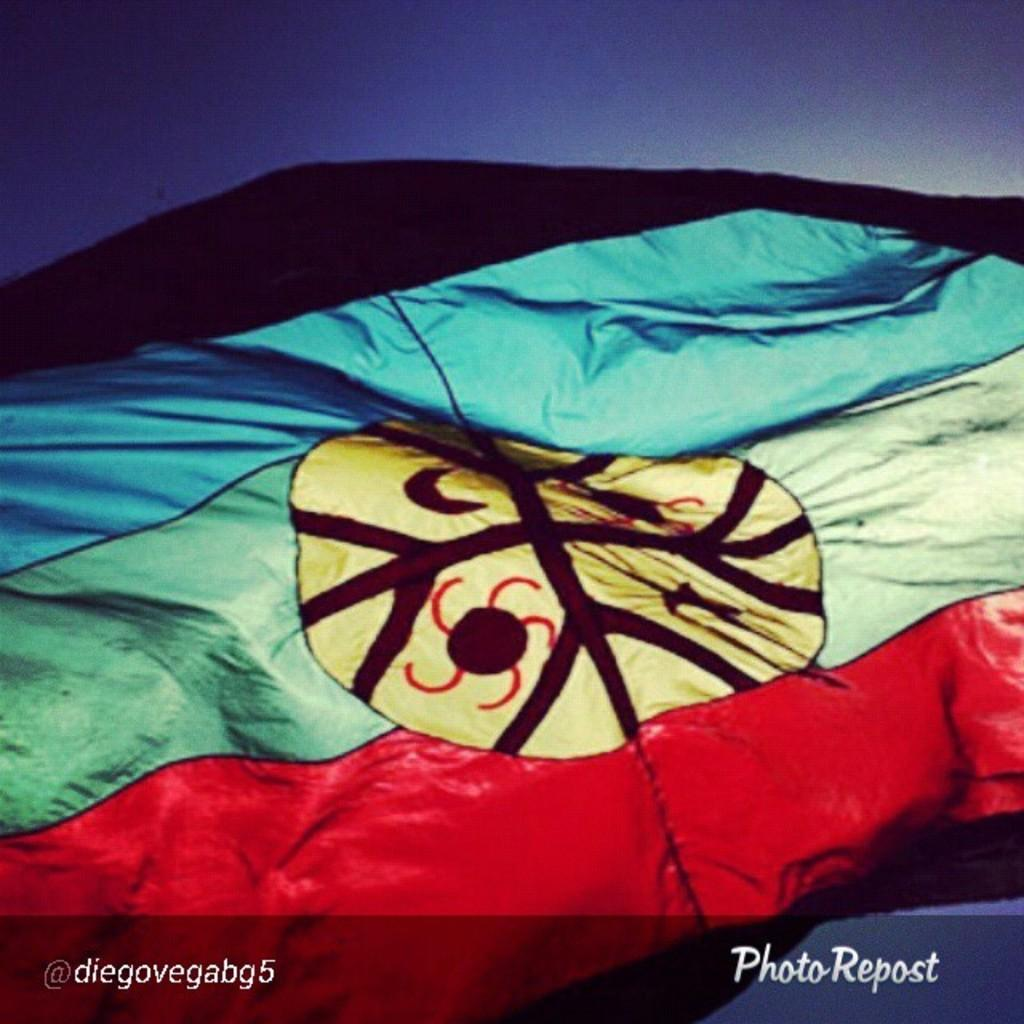What is the main object in the image? There is a cloth in the image. What colors are present on the cloth? The cloth has black, red, green, and yellow colors. What can be seen in the background of the image? The sky is visible in the background of the image. What color is the sky in the image? The sky is blue in color. Can you tell if the image has been edited or altered in any way? The image might be edited, as it is mentioned in the facts. What type of bait is used to catch fish in the image? There is no mention of fish or bait in the image; it features a cloth with specific colors and a blue sky in the background. What type of coat is the person wearing in the image? There is no person present in the image, only a cloth and the sky. 